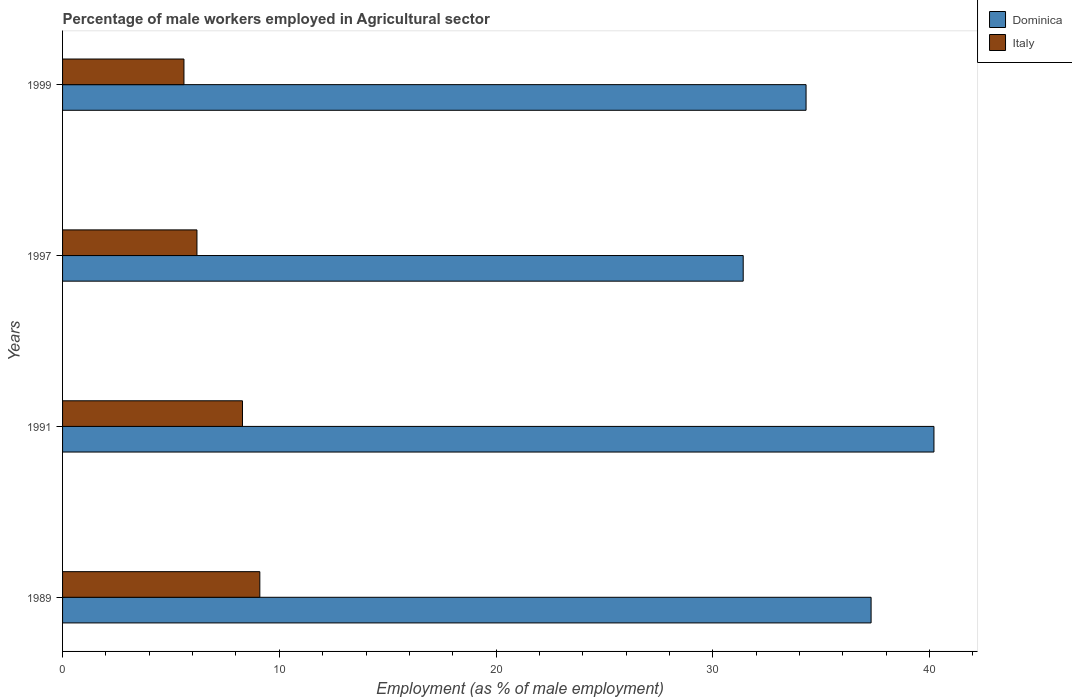How many groups of bars are there?
Offer a terse response. 4. How many bars are there on the 2nd tick from the bottom?
Provide a succinct answer. 2. What is the label of the 3rd group of bars from the top?
Provide a succinct answer. 1991. In how many cases, is the number of bars for a given year not equal to the number of legend labels?
Make the answer very short. 0. What is the percentage of male workers employed in Agricultural sector in Italy in 1991?
Make the answer very short. 8.3. Across all years, what is the maximum percentage of male workers employed in Agricultural sector in Dominica?
Keep it short and to the point. 40.2. Across all years, what is the minimum percentage of male workers employed in Agricultural sector in Italy?
Ensure brevity in your answer.  5.6. In which year was the percentage of male workers employed in Agricultural sector in Italy maximum?
Make the answer very short. 1989. What is the total percentage of male workers employed in Agricultural sector in Dominica in the graph?
Provide a short and direct response. 143.2. What is the difference between the percentage of male workers employed in Agricultural sector in Dominica in 1989 and that in 1991?
Provide a succinct answer. -2.9. What is the difference between the percentage of male workers employed in Agricultural sector in Dominica in 1991 and the percentage of male workers employed in Agricultural sector in Italy in 1999?
Make the answer very short. 34.6. What is the average percentage of male workers employed in Agricultural sector in Italy per year?
Your answer should be compact. 7.3. In the year 1999, what is the difference between the percentage of male workers employed in Agricultural sector in Dominica and percentage of male workers employed in Agricultural sector in Italy?
Offer a very short reply. 28.7. In how many years, is the percentage of male workers employed in Agricultural sector in Italy greater than 36 %?
Ensure brevity in your answer.  0. What is the ratio of the percentage of male workers employed in Agricultural sector in Italy in 1989 to that in 1997?
Ensure brevity in your answer.  1.47. Is the percentage of male workers employed in Agricultural sector in Dominica in 1989 less than that in 1997?
Ensure brevity in your answer.  No. What is the difference between the highest and the second highest percentage of male workers employed in Agricultural sector in Dominica?
Offer a terse response. 2.9. What is the difference between the highest and the lowest percentage of male workers employed in Agricultural sector in Dominica?
Your answer should be very brief. 8.8. What does the 2nd bar from the top in 1989 represents?
Offer a terse response. Dominica. How many bars are there?
Give a very brief answer. 8. How many years are there in the graph?
Ensure brevity in your answer.  4. What is the difference between two consecutive major ticks on the X-axis?
Your response must be concise. 10. Are the values on the major ticks of X-axis written in scientific E-notation?
Provide a succinct answer. No. Does the graph contain any zero values?
Your answer should be compact. No. Where does the legend appear in the graph?
Give a very brief answer. Top right. How are the legend labels stacked?
Provide a short and direct response. Vertical. What is the title of the graph?
Keep it short and to the point. Percentage of male workers employed in Agricultural sector. Does "Malawi" appear as one of the legend labels in the graph?
Provide a succinct answer. No. What is the label or title of the X-axis?
Give a very brief answer. Employment (as % of male employment). What is the label or title of the Y-axis?
Provide a succinct answer. Years. What is the Employment (as % of male employment) of Dominica in 1989?
Provide a short and direct response. 37.3. What is the Employment (as % of male employment) in Italy in 1989?
Provide a short and direct response. 9.1. What is the Employment (as % of male employment) of Dominica in 1991?
Offer a terse response. 40.2. What is the Employment (as % of male employment) of Italy in 1991?
Your answer should be compact. 8.3. What is the Employment (as % of male employment) of Dominica in 1997?
Ensure brevity in your answer.  31.4. What is the Employment (as % of male employment) in Italy in 1997?
Offer a very short reply. 6.2. What is the Employment (as % of male employment) of Dominica in 1999?
Ensure brevity in your answer.  34.3. What is the Employment (as % of male employment) in Italy in 1999?
Keep it short and to the point. 5.6. Across all years, what is the maximum Employment (as % of male employment) of Dominica?
Offer a very short reply. 40.2. Across all years, what is the maximum Employment (as % of male employment) of Italy?
Make the answer very short. 9.1. Across all years, what is the minimum Employment (as % of male employment) in Dominica?
Your response must be concise. 31.4. Across all years, what is the minimum Employment (as % of male employment) in Italy?
Keep it short and to the point. 5.6. What is the total Employment (as % of male employment) in Dominica in the graph?
Offer a terse response. 143.2. What is the total Employment (as % of male employment) of Italy in the graph?
Offer a very short reply. 29.2. What is the difference between the Employment (as % of male employment) of Italy in 1989 and that in 1991?
Your response must be concise. 0.8. What is the difference between the Employment (as % of male employment) of Italy in 1989 and that in 1997?
Offer a terse response. 2.9. What is the difference between the Employment (as % of male employment) in Italy in 1989 and that in 1999?
Provide a succinct answer. 3.5. What is the difference between the Employment (as % of male employment) of Dominica in 1991 and that in 1997?
Your answer should be very brief. 8.8. What is the difference between the Employment (as % of male employment) in Italy in 1991 and that in 1997?
Ensure brevity in your answer.  2.1. What is the difference between the Employment (as % of male employment) of Dominica in 1989 and the Employment (as % of male employment) of Italy in 1991?
Keep it short and to the point. 29. What is the difference between the Employment (as % of male employment) of Dominica in 1989 and the Employment (as % of male employment) of Italy in 1997?
Provide a short and direct response. 31.1. What is the difference between the Employment (as % of male employment) in Dominica in 1989 and the Employment (as % of male employment) in Italy in 1999?
Make the answer very short. 31.7. What is the difference between the Employment (as % of male employment) in Dominica in 1991 and the Employment (as % of male employment) in Italy in 1997?
Give a very brief answer. 34. What is the difference between the Employment (as % of male employment) of Dominica in 1991 and the Employment (as % of male employment) of Italy in 1999?
Make the answer very short. 34.6. What is the difference between the Employment (as % of male employment) in Dominica in 1997 and the Employment (as % of male employment) in Italy in 1999?
Your answer should be very brief. 25.8. What is the average Employment (as % of male employment) of Dominica per year?
Your response must be concise. 35.8. What is the average Employment (as % of male employment) in Italy per year?
Keep it short and to the point. 7.3. In the year 1989, what is the difference between the Employment (as % of male employment) in Dominica and Employment (as % of male employment) in Italy?
Give a very brief answer. 28.2. In the year 1991, what is the difference between the Employment (as % of male employment) of Dominica and Employment (as % of male employment) of Italy?
Provide a succinct answer. 31.9. In the year 1997, what is the difference between the Employment (as % of male employment) in Dominica and Employment (as % of male employment) in Italy?
Your answer should be very brief. 25.2. In the year 1999, what is the difference between the Employment (as % of male employment) of Dominica and Employment (as % of male employment) of Italy?
Offer a very short reply. 28.7. What is the ratio of the Employment (as % of male employment) in Dominica in 1989 to that in 1991?
Your response must be concise. 0.93. What is the ratio of the Employment (as % of male employment) in Italy in 1989 to that in 1991?
Ensure brevity in your answer.  1.1. What is the ratio of the Employment (as % of male employment) in Dominica in 1989 to that in 1997?
Keep it short and to the point. 1.19. What is the ratio of the Employment (as % of male employment) of Italy in 1989 to that in 1997?
Provide a short and direct response. 1.47. What is the ratio of the Employment (as % of male employment) of Dominica in 1989 to that in 1999?
Your answer should be compact. 1.09. What is the ratio of the Employment (as % of male employment) of Italy in 1989 to that in 1999?
Provide a succinct answer. 1.62. What is the ratio of the Employment (as % of male employment) in Dominica in 1991 to that in 1997?
Offer a terse response. 1.28. What is the ratio of the Employment (as % of male employment) of Italy in 1991 to that in 1997?
Keep it short and to the point. 1.34. What is the ratio of the Employment (as % of male employment) in Dominica in 1991 to that in 1999?
Keep it short and to the point. 1.17. What is the ratio of the Employment (as % of male employment) in Italy in 1991 to that in 1999?
Keep it short and to the point. 1.48. What is the ratio of the Employment (as % of male employment) of Dominica in 1997 to that in 1999?
Keep it short and to the point. 0.92. What is the ratio of the Employment (as % of male employment) in Italy in 1997 to that in 1999?
Make the answer very short. 1.11. What is the difference between the highest and the second highest Employment (as % of male employment) in Dominica?
Offer a very short reply. 2.9. What is the difference between the highest and the second highest Employment (as % of male employment) in Italy?
Ensure brevity in your answer.  0.8. What is the difference between the highest and the lowest Employment (as % of male employment) in Dominica?
Your answer should be very brief. 8.8. What is the difference between the highest and the lowest Employment (as % of male employment) of Italy?
Your answer should be very brief. 3.5. 